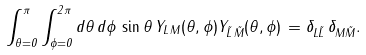Convert formula to latex. <formula><loc_0><loc_0><loc_500><loc_500>\int _ { \theta = 0 } ^ { \pi } \int _ { \phi = 0 } ^ { 2 \pi } d \theta \, d \phi \, \sin \theta \, Y _ { L \, M } ( \theta , \phi ) Y _ { \tilde { L } \, \tilde { M } } ( \theta , \phi ) \, = \delta _ { L \tilde { L } } \, \delta _ { M \tilde { M } } .</formula> 